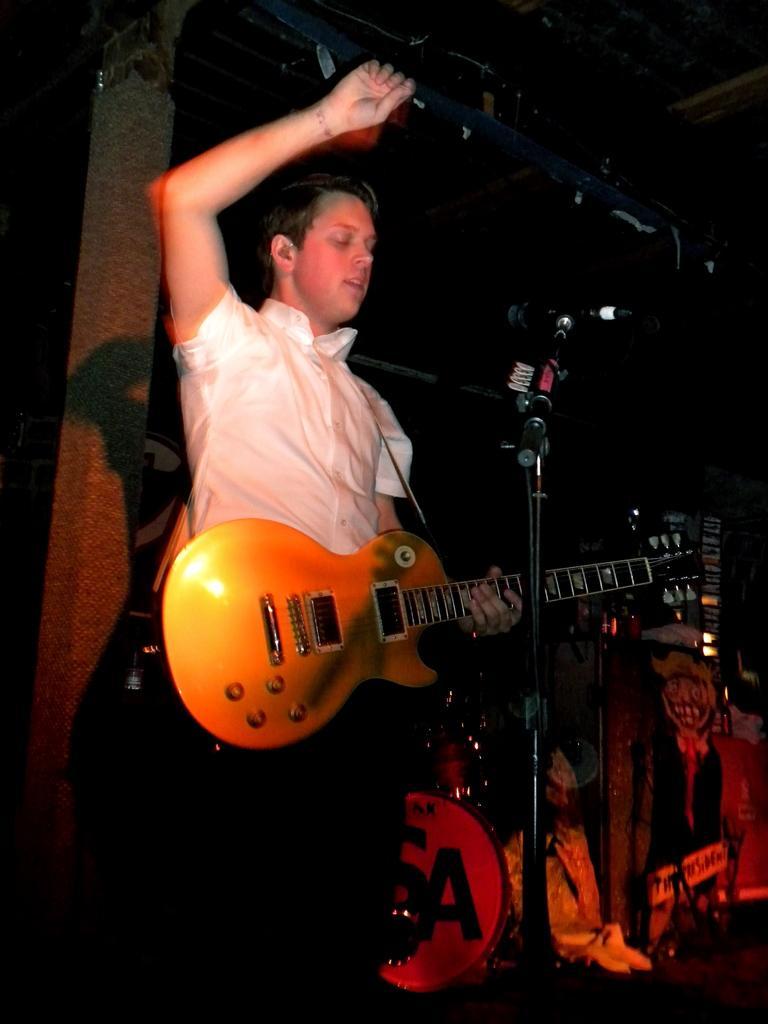Describe this image in one or two sentences. In this image I can see a man is standing and I can see he is holding a guitar. I can also see he is wearing white shirt and in the front of him I can see a mic. In the background I can see few stuffs and few clothes. 